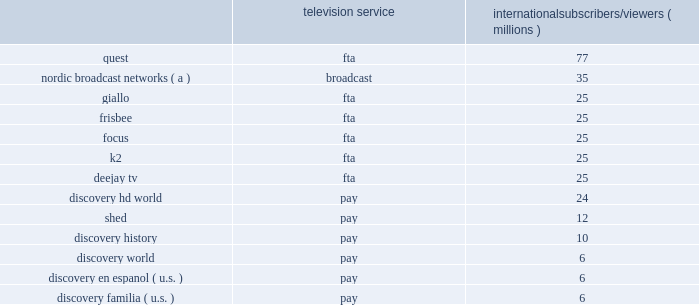International networks international networks generated revenues of $ 3.0 billion and adjusted oibda of $ 848 million during 2016 , which represented 47% ( 47 % ) and 35% ( 35 % ) of our total consolidated revenues and adjusted oibda , respectively .
Our international networks segment principally consists of national and pan-regional television networks and brands that are delivered across multiple distribution platforms .
This segment generates revenue from operations in virtually every pay-tv market in the world through an infrastructure that includes operational centers in london , warsaw , milan , singapore and miami .
Global brands include discovery channel , animal planet , tlc , id , science channel and turbo ( known as velocity in the u.s. ) , along with brands exclusive to international networks , including eurosport , real time , dmax and discovery kids .
As of december 31 , 2016 , international networks operated over 400 unique distribution feeds in over 40 languages with channel feeds customized according to language needs and advertising sales opportunities .
International networks also has fta and broadcast networks in europe and the middle east and broadcast networks in germany , norway and sweden , and continues to pursue further international expansion .
Fta networks generate a significant portion of international networks' revenue .
The penetration and growth rates of television services vary across countries and territories depending on numerous factors including the dominance of different television platforms in local markets .
While pay-tv services have greater penetration in certain markets , fta or broadcast television is dominant in others .
International networks has a large international distribution platform for its 37 networks , with as many as 13 networks distributed in any particular country or territory across the more than 220 countries and territories around the world .
International networks pursues distribution across all television platforms based on the specific dynamics of local markets and relevant commercial agreements .
In addition to the global networks described in the overview section above , we operate networks internationally that utilize the following brands : 2022 eurosport is the leading sports entertainment provider across europe with the following tv brands : eurosport , eurosport 2 and eurosportnews , reaching viewers across europe and asia , as well as eurosport digital , which includes eurosport player and eurosport.com .
2022 viewing subscribers reached by each brand as of december 31 , 2016 were as follows : eurosport : 133 million ; eurosport 2 : 65 million ; and eurosportnews : 9 million .
2022 eurosport telecasts live sporting events with both local and pan-regional appeal and its events focus on winter sports , cycling and tennis , including the tour de france and it is the home of grand slam tennis with all four tournaments .
Important local sports rights include bundesliga and motogp .
In addition , eurosport has increasingly invested in more exclusive and localized rights to drive local audience and commercial relevance .
2022 we have acquired the exclusive broadcast rights across all media platforms throughout europe for the four olympic games between 2018 and 2024 for 20ac1.3 billion ( $ 1.5 billion as of december 31 , 2016 ) .
The broadcast rights exclude france for the olympic games in 2018 and 2020 , and exclude russia .
In addition to fta broadcasts for the olympic games , many of these events are set to air on eurosport's pay-tv and digital platforms .
2022 on november 2 , 2016 , we announced a long-term agreement and joint venture partnership with bamtech ( "mlbam" ) a technology services and video streaming company , and subsidiary of major league baseball's digital business , that includes the formation of bamtech europe , a joint venture that will provide digital technology services to a broad set of both sports and entertainment clients across europe .
2022 as of december 31 , 2016 , dmax reached approximately 103 million viewers through fta networks , according to internal estimates .
2022 dmax is a men 2019s factual entertainment channel in asia and europe .
2022 discovery kids reached approximately 121 million viewers , according to internal estimates , as of december 31 , 2016 .
2022 discovery kids is a leading children's network in latin america and asia .
Our international networks segment also owns and operates the following regional television networks , which reached the following number of subscribers and viewers via pay and fta or broadcast networks , respectively , as of december 31 , 2016 : television service international subscribers/viewers ( millions ) .
( a ) number of subscribers corresponds to the sum of the subscribers to each of the nordic broadcast networks in sweden , norway , finland and denmark subject to retransmission agreements with pay-tv providers .
The nordic broadcast networks include kanal 5 , kanal 9 , and kanal 11 in sweden , tv norge , max , fem and vox in norway , tv 5 , kutonen , and frii in finland , and kanal 4 , kanal 5 , 6'eren , and canal 9 in denmark .
Similar to u.s .
Networks , a significant source of revenue for international networks relates to fees charged to operators who distribute our linear networks .
Such operators primarily include cable and dth satellite service providers .
International television markets vary in their stages of development .
Some markets , such as the u.k. , are more advanced digital television markets , while others remain in the analog environment with varying degrees of investment from operators to expand channel capacity or convert to digital technologies .
Common practice in some markets results in long-term contractual distribution relationships , while customers in other markets renew contracts annually .
Distribution revenue for our international networks segment is largely dependent on the number of subscribers that receive our networks or content , the rates negotiated in the distributor agreements , and the market demand for the content that we provide .
The other significant source of revenue for international networks relates to advertising sold on our television networks and across distribution platforms , similar to u.s .
Networks .
Advertising revenue is dependent upon a number of factors , including the development of pay and fta television markets , the number of subscribers to and viewers of our channels , viewership demographics , the popularity of our programming , and our ability to sell commercial time over a portfolio of channels on multiple platforms .
In certain markets , our advertising sales business operates with in-house sales teams , while we rely on external sales representation services in other markets .
In developing television markets , advertising revenue growth results from continued subscriber growth , our localization strategy , and the shift of advertising spending from traditional broadcast networks to channels .
What percentage of eurosport viewing subscribers reached were due to eurosport 2 network? 
Computations: (65 / ((133 + 65) + 9))
Answer: 0.31401. International networks international networks generated revenues of $ 3.0 billion and adjusted oibda of $ 848 million during 2016 , which represented 47% ( 47 % ) and 35% ( 35 % ) of our total consolidated revenues and adjusted oibda , respectively .
Our international networks segment principally consists of national and pan-regional television networks and brands that are delivered across multiple distribution platforms .
This segment generates revenue from operations in virtually every pay-tv market in the world through an infrastructure that includes operational centers in london , warsaw , milan , singapore and miami .
Global brands include discovery channel , animal planet , tlc , id , science channel and turbo ( known as velocity in the u.s. ) , along with brands exclusive to international networks , including eurosport , real time , dmax and discovery kids .
As of december 31 , 2016 , international networks operated over 400 unique distribution feeds in over 40 languages with channel feeds customized according to language needs and advertising sales opportunities .
International networks also has fta and broadcast networks in europe and the middle east and broadcast networks in germany , norway and sweden , and continues to pursue further international expansion .
Fta networks generate a significant portion of international networks' revenue .
The penetration and growth rates of television services vary across countries and territories depending on numerous factors including the dominance of different television platforms in local markets .
While pay-tv services have greater penetration in certain markets , fta or broadcast television is dominant in others .
International networks has a large international distribution platform for its 37 networks , with as many as 13 networks distributed in any particular country or territory across the more than 220 countries and territories around the world .
International networks pursues distribution across all television platforms based on the specific dynamics of local markets and relevant commercial agreements .
In addition to the global networks described in the overview section above , we operate networks internationally that utilize the following brands : 2022 eurosport is the leading sports entertainment provider across europe with the following tv brands : eurosport , eurosport 2 and eurosportnews , reaching viewers across europe and asia , as well as eurosport digital , which includes eurosport player and eurosport.com .
2022 viewing subscribers reached by each brand as of december 31 , 2016 were as follows : eurosport : 133 million ; eurosport 2 : 65 million ; and eurosportnews : 9 million .
2022 eurosport telecasts live sporting events with both local and pan-regional appeal and its events focus on winter sports , cycling and tennis , including the tour de france and it is the home of grand slam tennis with all four tournaments .
Important local sports rights include bundesliga and motogp .
In addition , eurosport has increasingly invested in more exclusive and localized rights to drive local audience and commercial relevance .
2022 we have acquired the exclusive broadcast rights across all media platforms throughout europe for the four olympic games between 2018 and 2024 for 20ac1.3 billion ( $ 1.5 billion as of december 31 , 2016 ) .
The broadcast rights exclude france for the olympic games in 2018 and 2020 , and exclude russia .
In addition to fta broadcasts for the olympic games , many of these events are set to air on eurosport's pay-tv and digital platforms .
2022 on november 2 , 2016 , we announced a long-term agreement and joint venture partnership with bamtech ( "mlbam" ) a technology services and video streaming company , and subsidiary of major league baseball's digital business , that includes the formation of bamtech europe , a joint venture that will provide digital technology services to a broad set of both sports and entertainment clients across europe .
2022 as of december 31 , 2016 , dmax reached approximately 103 million viewers through fta networks , according to internal estimates .
2022 dmax is a men 2019s factual entertainment channel in asia and europe .
2022 discovery kids reached approximately 121 million viewers , according to internal estimates , as of december 31 , 2016 .
2022 discovery kids is a leading children's network in latin america and asia .
Our international networks segment also owns and operates the following regional television networks , which reached the following number of subscribers and viewers via pay and fta or broadcast networks , respectively , as of december 31 , 2016 : television service international subscribers/viewers ( millions ) .
( a ) number of subscribers corresponds to the sum of the subscribers to each of the nordic broadcast networks in sweden , norway , finland and denmark subject to retransmission agreements with pay-tv providers .
The nordic broadcast networks include kanal 5 , kanal 9 , and kanal 11 in sweden , tv norge , max , fem and vox in norway , tv 5 , kutonen , and frii in finland , and kanal 4 , kanal 5 , 6'eren , and canal 9 in denmark .
Similar to u.s .
Networks , a significant source of revenue for international networks relates to fees charged to operators who distribute our linear networks .
Such operators primarily include cable and dth satellite service providers .
International television markets vary in their stages of development .
Some markets , such as the u.k. , are more advanced digital television markets , while others remain in the analog environment with varying degrees of investment from operators to expand channel capacity or convert to digital technologies .
Common practice in some markets results in long-term contractual distribution relationships , while customers in other markets renew contracts annually .
Distribution revenue for our international networks segment is largely dependent on the number of subscribers that receive our networks or content , the rates negotiated in the distributor agreements , and the market demand for the content that we provide .
The other significant source of revenue for international networks relates to advertising sold on our television networks and across distribution platforms , similar to u.s .
Networks .
Advertising revenue is dependent upon a number of factors , including the development of pay and fta television markets , the number of subscribers to and viewers of our channels , viewership demographics , the popularity of our programming , and our ability to sell commercial time over a portfolio of channels on multiple platforms .
In certain markets , our advertising sales business operates with in-house sales teams , while we rely on external sales representation services in other markets .
In developing television markets , advertising revenue growth results from continued subscriber growth , our localization strategy , and the shift of advertising spending from traditional broadcast networks to channels .
What percentage of eurosport viewing subscribers reached were due to eurosport 2 network? 
Computations: (133 / ((133 + 65) + 9))
Answer: 0.64251. 